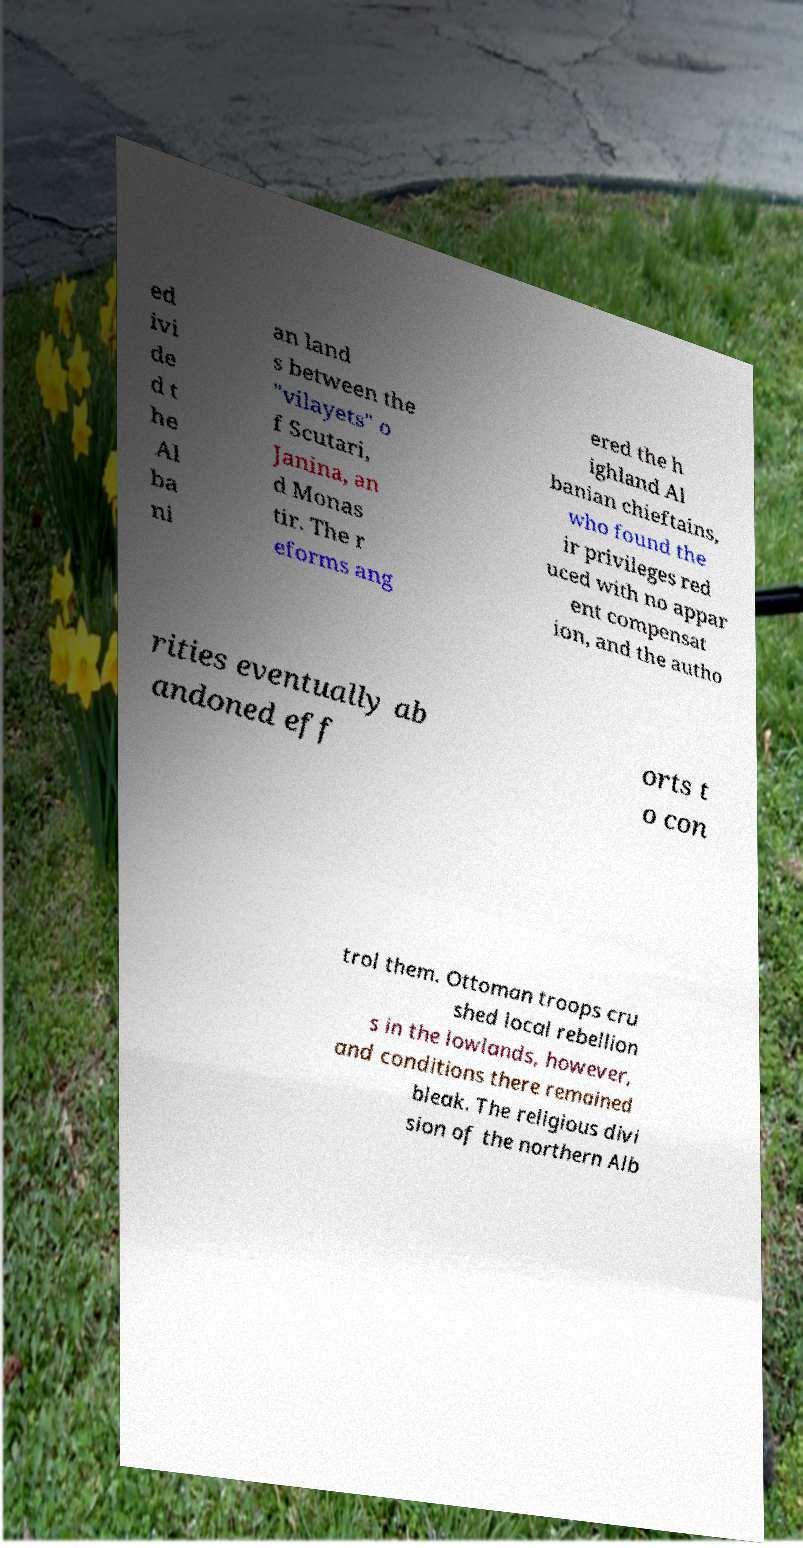Can you accurately transcribe the text from the provided image for me? ed ivi de d t he Al ba ni an land s between the "vilayets" o f Scutari, Janina, an d Monas tir. The r eforms ang ered the h ighland Al banian chieftains, who found the ir privileges red uced with no appar ent compensat ion, and the autho rities eventually ab andoned eff orts t o con trol them. Ottoman troops cru shed local rebellion s in the lowlands, however, and conditions there remained bleak. The religious divi sion of the northern Alb 